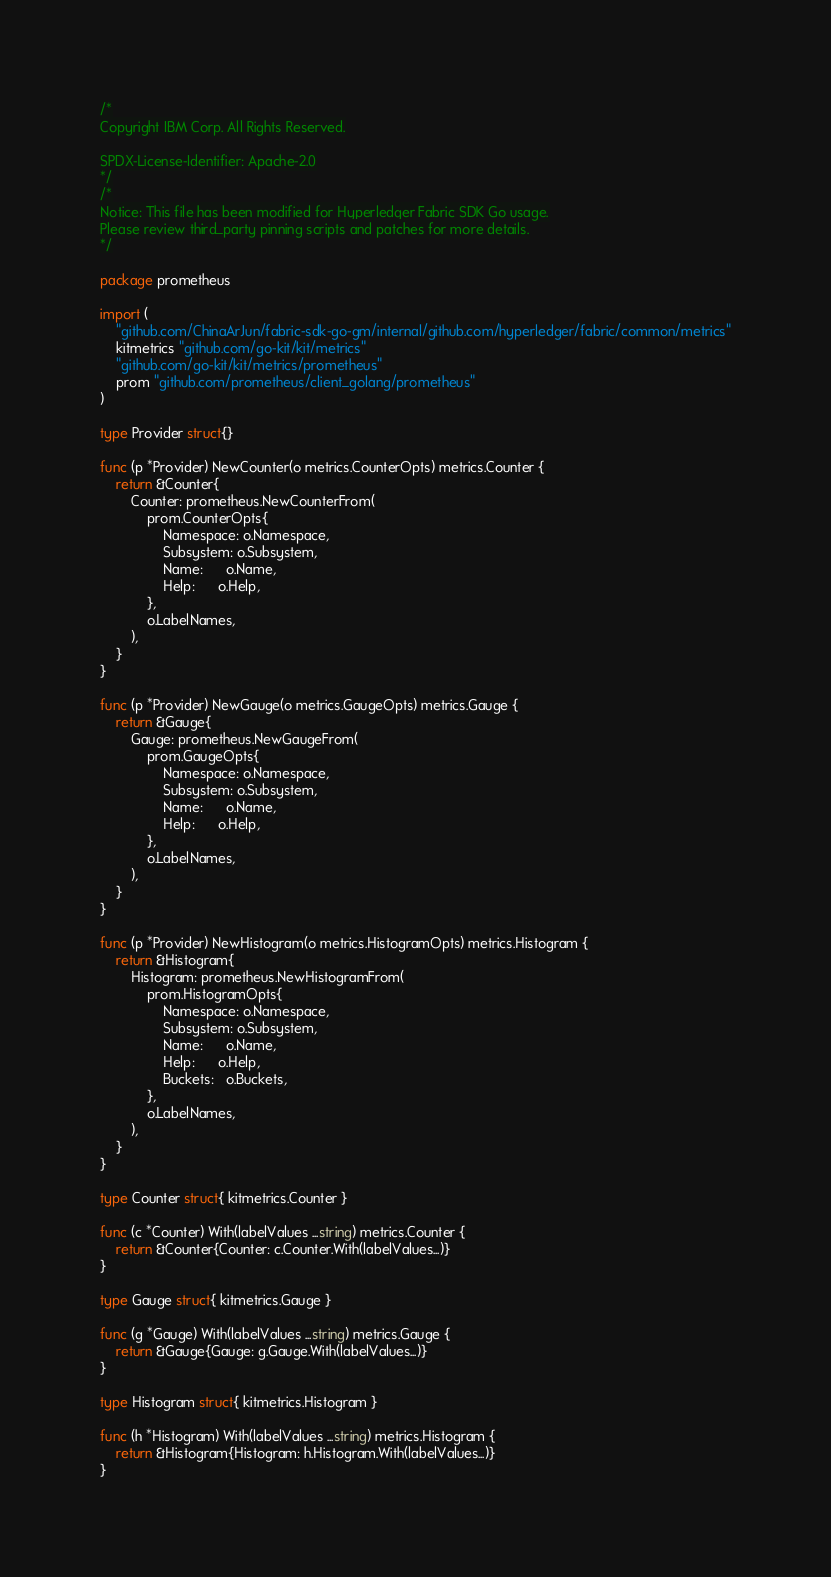<code> <loc_0><loc_0><loc_500><loc_500><_Go_>/*
Copyright IBM Corp. All Rights Reserved.

SPDX-License-Identifier: Apache-2.0
*/
/*
Notice: This file has been modified for Hyperledger Fabric SDK Go usage.
Please review third_party pinning scripts and patches for more details.
*/

package prometheus

import (
	"github.com/ChinaArJun/fabric-sdk-go-gm/internal/github.com/hyperledger/fabric/common/metrics"
	kitmetrics "github.com/go-kit/kit/metrics"
	"github.com/go-kit/kit/metrics/prometheus"
	prom "github.com/prometheus/client_golang/prometheus"
)

type Provider struct{}

func (p *Provider) NewCounter(o metrics.CounterOpts) metrics.Counter {
	return &Counter{
		Counter: prometheus.NewCounterFrom(
			prom.CounterOpts{
				Namespace: o.Namespace,
				Subsystem: o.Subsystem,
				Name:      o.Name,
				Help:      o.Help,
			},
			o.LabelNames,
		),
	}
}

func (p *Provider) NewGauge(o metrics.GaugeOpts) metrics.Gauge {
	return &Gauge{
		Gauge: prometheus.NewGaugeFrom(
			prom.GaugeOpts{
				Namespace: o.Namespace,
				Subsystem: o.Subsystem,
				Name:      o.Name,
				Help:      o.Help,
			},
			o.LabelNames,
		),
	}
}

func (p *Provider) NewHistogram(o metrics.HistogramOpts) metrics.Histogram {
	return &Histogram{
		Histogram: prometheus.NewHistogramFrom(
			prom.HistogramOpts{
				Namespace: o.Namespace,
				Subsystem: o.Subsystem,
				Name:      o.Name,
				Help:      o.Help,
				Buckets:   o.Buckets,
			},
			o.LabelNames,
		),
	}
}

type Counter struct{ kitmetrics.Counter }

func (c *Counter) With(labelValues ...string) metrics.Counter {
	return &Counter{Counter: c.Counter.With(labelValues...)}
}

type Gauge struct{ kitmetrics.Gauge }

func (g *Gauge) With(labelValues ...string) metrics.Gauge {
	return &Gauge{Gauge: g.Gauge.With(labelValues...)}
}

type Histogram struct{ kitmetrics.Histogram }

func (h *Histogram) With(labelValues ...string) metrics.Histogram {
	return &Histogram{Histogram: h.Histogram.With(labelValues...)}
}
</code> 